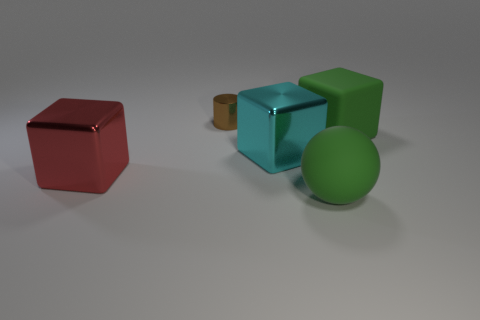Subtract all shiny cubes. How many cubes are left? 1 Add 4 green blocks. How many objects exist? 9 Subtract 1 cubes. How many cubes are left? 2 Subtract all cylinders. How many objects are left? 4 Subtract 0 yellow spheres. How many objects are left? 5 Subtract all purple cubes. Subtract all blue spheres. How many cubes are left? 3 Subtract all large matte blocks. Subtract all big cyan shiny blocks. How many objects are left? 3 Add 5 small metallic objects. How many small metallic objects are left? 6 Add 5 tiny brown shiny cylinders. How many tiny brown shiny cylinders exist? 6 